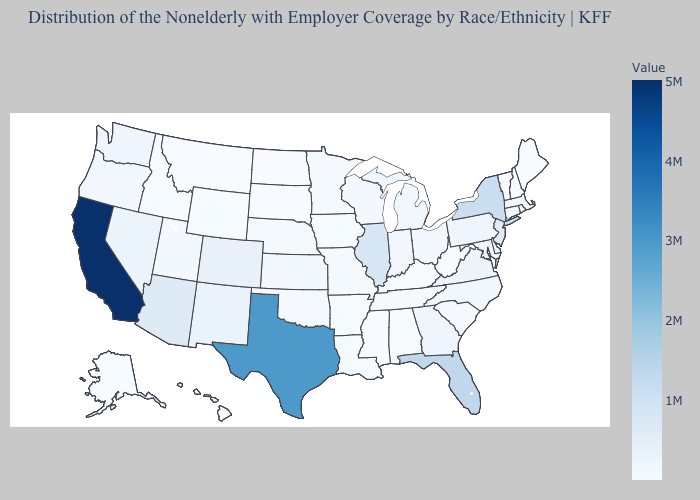Does New York have the highest value in the Northeast?
Quick response, please. Yes. Does West Virginia have a higher value than New Jersey?
Give a very brief answer. No. Which states hav the highest value in the Northeast?
Write a very short answer. New York. Among the states that border Connecticut , which have the highest value?
Concise answer only. New York. Which states have the lowest value in the USA?
Concise answer only. Vermont. Is the legend a continuous bar?
Be succinct. Yes. Among the states that border Alabama , does Tennessee have the highest value?
Answer briefly. No. 